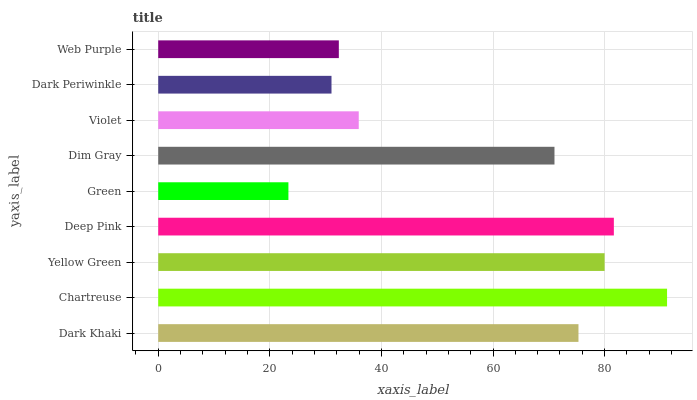Is Green the minimum?
Answer yes or no. Yes. Is Chartreuse the maximum?
Answer yes or no. Yes. Is Yellow Green the minimum?
Answer yes or no. No. Is Yellow Green the maximum?
Answer yes or no. No. Is Chartreuse greater than Yellow Green?
Answer yes or no. Yes. Is Yellow Green less than Chartreuse?
Answer yes or no. Yes. Is Yellow Green greater than Chartreuse?
Answer yes or no. No. Is Chartreuse less than Yellow Green?
Answer yes or no. No. Is Dim Gray the high median?
Answer yes or no. Yes. Is Dim Gray the low median?
Answer yes or no. Yes. Is Violet the high median?
Answer yes or no. No. Is Chartreuse the low median?
Answer yes or no. No. 